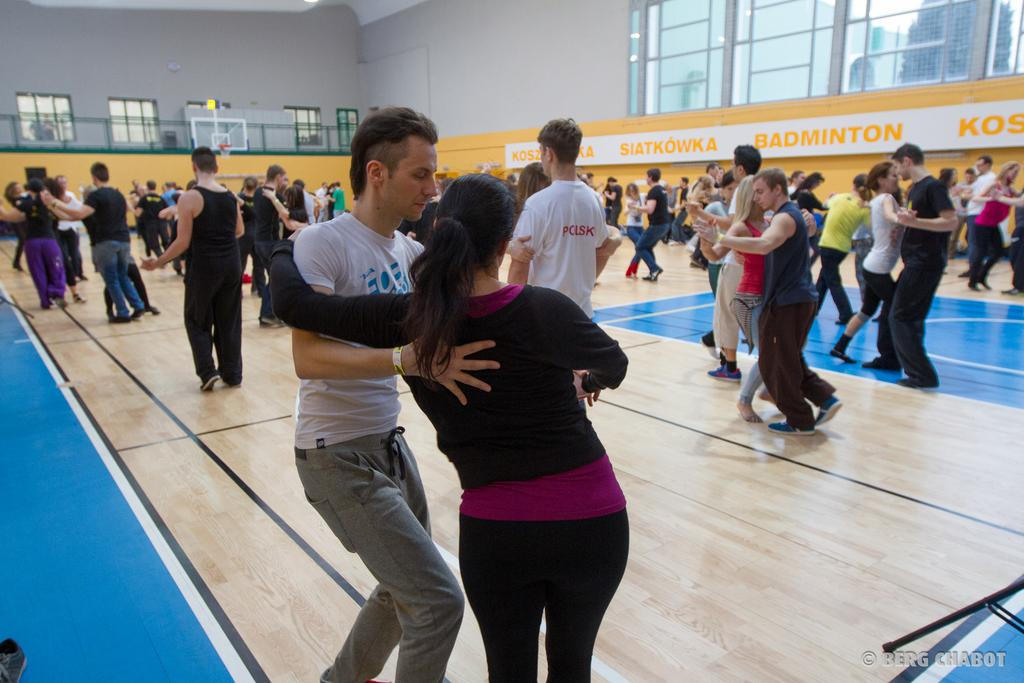What type of area is depicted in the image? There is a basketball court in the image. What activity are the people engaged in on the basketball court? People are dancing on the basketball court. What objects can be seen in the image besides the basketball court and people? There are boards visible in the image. What architectural feature is present on the wall in the image? There are windows on the wall in the image. How does the basketball court contribute to the profit of the company in the image? The image does not depict a company or any financial aspect, so it is not possible to determine how the basketball court contributes to profit. 